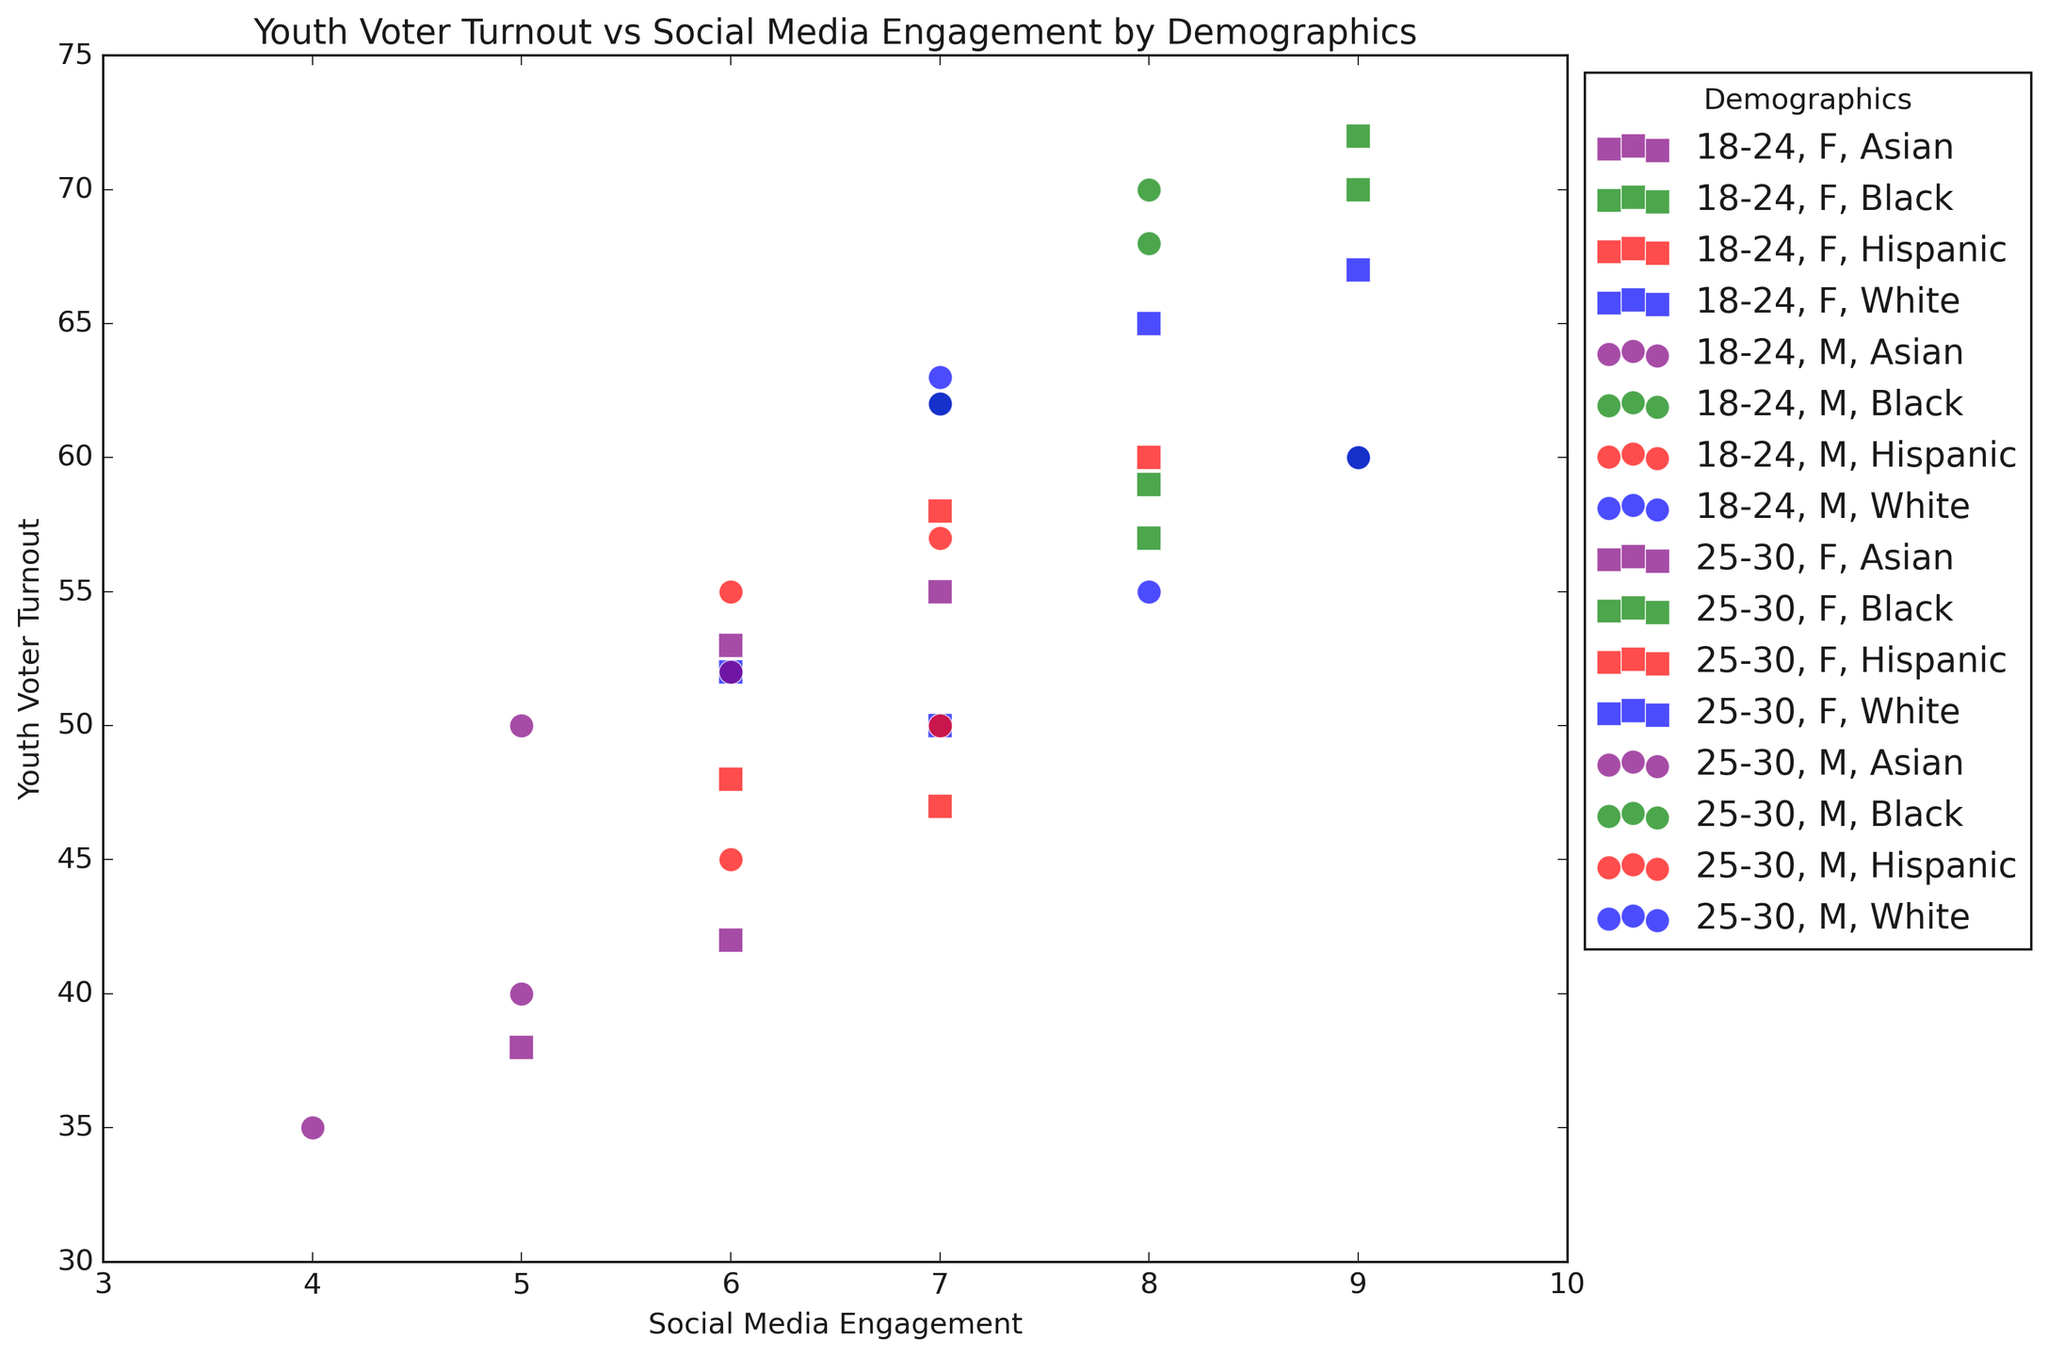What demographic group has the highest youth voter turnout? To find the highest youth voter turnout, observe the y-axis for the highest data point. The data at (9, 72) represents 25-30, Female, Black.
Answer: 25-30, Female, Black Comparing 18-24 and 25-30 age groups, which shows a stronger correlation between social media engagement and voter turnout? Visually assess the trend lines of data points for each age group. The 25-30 age group shows a stronger upward trend, indicating a stronger correlation.
Answer: 25-30 age group Which gender has a higher average voter turnout in the 18-24 age group? Calculate the average voter turnout for males and females separately in 18-24 by summing their voter turnout values and dividing by their count. Males have an average of (55+60+45+40+60+62+50+35)/8 = 50.875. Females have an average of (50+57+47+42+52+59+48+38)/8 = 49.125.
Answer: Male For the 25-30 age group, does social media engagement correlate more strongly with voter turnout among any particular race? Identify the apparent trends by visually assessing the spread and alignment of data points for different races. Black data points (green) show the most consistent upward trend.
Answer: Black How does the voter turnout of the 18-24, Male, White demographic compare to the 25-30, Female, Asian demographic? Locate the points for both demographics: 18-24, Male, White has points at (8, 55) and (9, 60). 25-30, Female, Asian has points at (6, 53) and (7, 55). While the 18-24, Male, White demographic shows a range from 55 to 60, the 25-30, Female, Asian shows a range from 53 to 55.
Answer: 25-30, Female, Asian has slightly lower turnout What's the average social media engagement level for the Hispanic demographic across all ages and genders? Sum the social media engagement values for all Hispanic data points and divide by their count: (6 + 7 + 7 + 6 + 7 + 8) / 6 = 6.83.
Answer: 6.83 Are Asian males in the 18-24 age group more or less engaged on social media compared to Asian females in the same age group? Compare their engagement levels: Asian males in 18-24 have values of (5, 4), and females in 18-24 have (6, 5). Males have an average of (5+4)/2 = 4.5, and females have an average of (6+5)/2 = 5.5.
Answer: Less engaged Which demographic group has the lowest social media engagement? Identify the lowest point on the x-axis. The data point at (4, 35) represents 18-24, Male, Asian.
Answer: 18-24, Male, Asian For the 18-24 age group, which race shows the greatest variation in voter turnout? Observe the spread of data points on the y-axis for each race. Black data points show turnout ranging from 57 to 62, indicating the greatest variation.
Answer: Black 